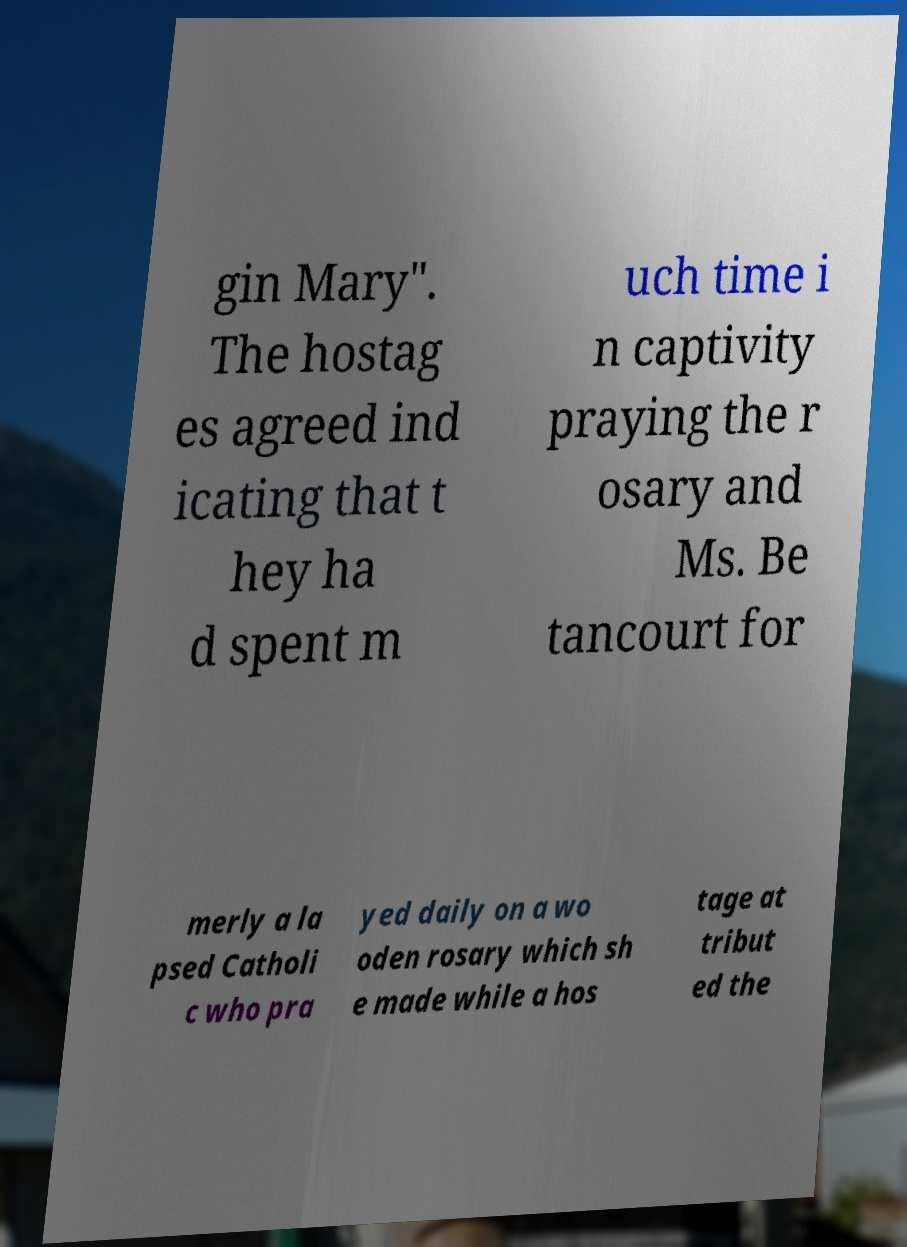There's text embedded in this image that I need extracted. Can you transcribe it verbatim? gin Mary". The hostag es agreed ind icating that t hey ha d spent m uch time i n captivity praying the r osary and Ms. Be tancourt for merly a la psed Catholi c who pra yed daily on a wo oden rosary which sh e made while a hos tage at tribut ed the 